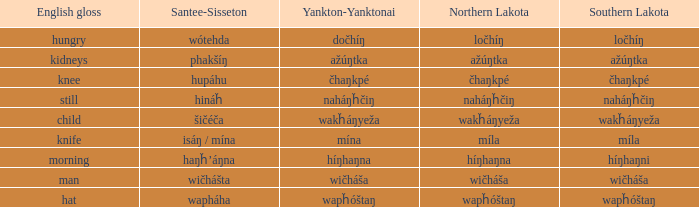Name the english gloss for haŋȟ’áŋna Morning. 